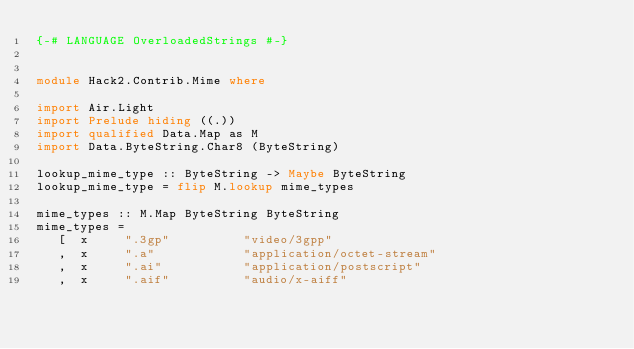Convert code to text. <code><loc_0><loc_0><loc_500><loc_500><_Haskell_>{-# LANGUAGE OverloadedStrings #-}


module Hack2.Contrib.Mime where

import Air.Light
import Prelude hiding ((.))
import qualified Data.Map as M
import Data.ByteString.Char8 (ByteString)

lookup_mime_type :: ByteString -> Maybe ByteString
lookup_mime_type = flip M.lookup mime_types

mime_types :: M.Map ByteString ByteString
mime_types = 
   [  x     ".3gp"          "video/3gpp"
   ,  x     ".a"            "application/octet-stream"
   ,  x     ".ai"           "application/postscript"
   ,  x     ".aif"          "audio/x-aiff"</code> 